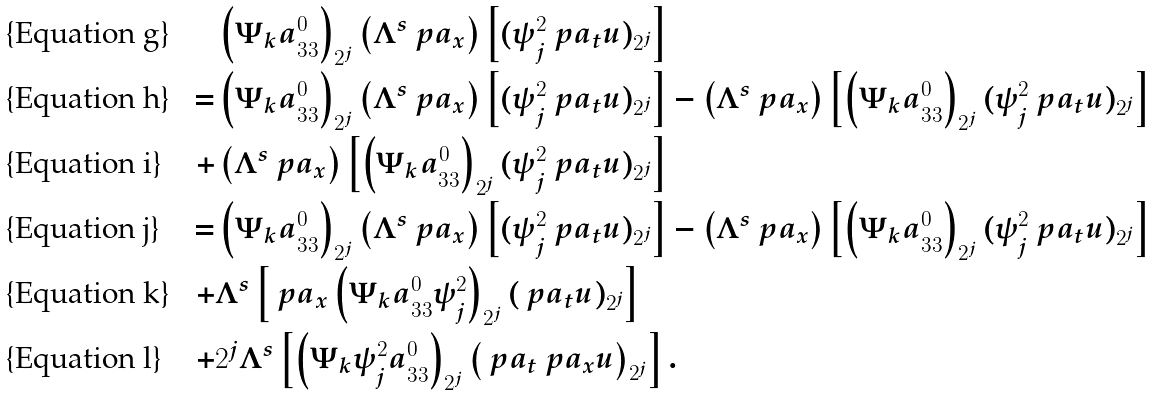Convert formula to latex. <formula><loc_0><loc_0><loc_500><loc_500>& \left ( \Psi _ { k } { a } _ { 3 3 } ^ { 0 } \right ) _ { 2 ^ { j } } \left ( \Lambda ^ { s } \ p a _ { x } \right ) \left [ ( \psi _ { j } ^ { 2 } \ p a _ { t } u ) _ { 2 ^ { j } } \right ] \\ = & \left ( \Psi _ { k } { a } _ { 3 3 } ^ { 0 } \right ) _ { 2 ^ { j } } \left ( \Lambda ^ { s } \ p a _ { x } \right ) \left [ ( \psi _ { j } ^ { 2 } \ p a _ { t } u ) _ { 2 ^ { j } } \right ] - \left ( \Lambda ^ { s } \ p a _ { x } \right ) \left [ \left ( \Psi _ { k } { a } _ { 3 3 } ^ { 0 } \right ) _ { 2 ^ { j } } ( \psi _ { j } ^ { 2 } \ p a _ { t } u ) _ { 2 ^ { j } } \right ] \\ + & \left ( \Lambda ^ { s } \ p a _ { x } \right ) \left [ \left ( \Psi _ { k } { a } _ { 3 3 } ^ { 0 } \right ) _ { 2 ^ { j } } ( \psi _ { j } ^ { 2 } \ p a _ { t } u ) _ { 2 ^ { j } } \right ] \\ = & \left ( \Psi _ { k } { a } _ { 3 3 } ^ { 0 } \right ) _ { 2 ^ { j } } \left ( \Lambda ^ { s } \ p a _ { x } \right ) \left [ ( \psi _ { j } ^ { 2 } \ p a _ { t } u ) _ { 2 ^ { j } } \right ] - \left ( \Lambda ^ { s } \ p a _ { x } \right ) \left [ \left ( \Psi _ { k } { a } _ { 3 3 } ^ { 0 } \right ) _ { 2 ^ { j } } ( \psi _ { j } ^ { 2 } \ p a _ { t } u ) _ { 2 ^ { j } } \right ] \\ + & \Lambda ^ { s } \left [ \ p a _ { x } \left ( \Psi _ { k } { a } _ { 3 3 } ^ { 0 } \psi _ { j } ^ { 2 } \right ) _ { 2 ^ { j } } ( \ p a _ { t } u ) _ { 2 ^ { j } } \right ] \\ + & 2 ^ { j } \Lambda ^ { s } \left [ \left ( \Psi _ { k } \psi _ { j } ^ { 2 } { a } _ { 3 3 } ^ { 0 } \right ) _ { 2 ^ { j } } \left ( \ p a _ { t } \ p a _ { x } u \right ) _ { 2 ^ { j } } \right ] .</formula> 